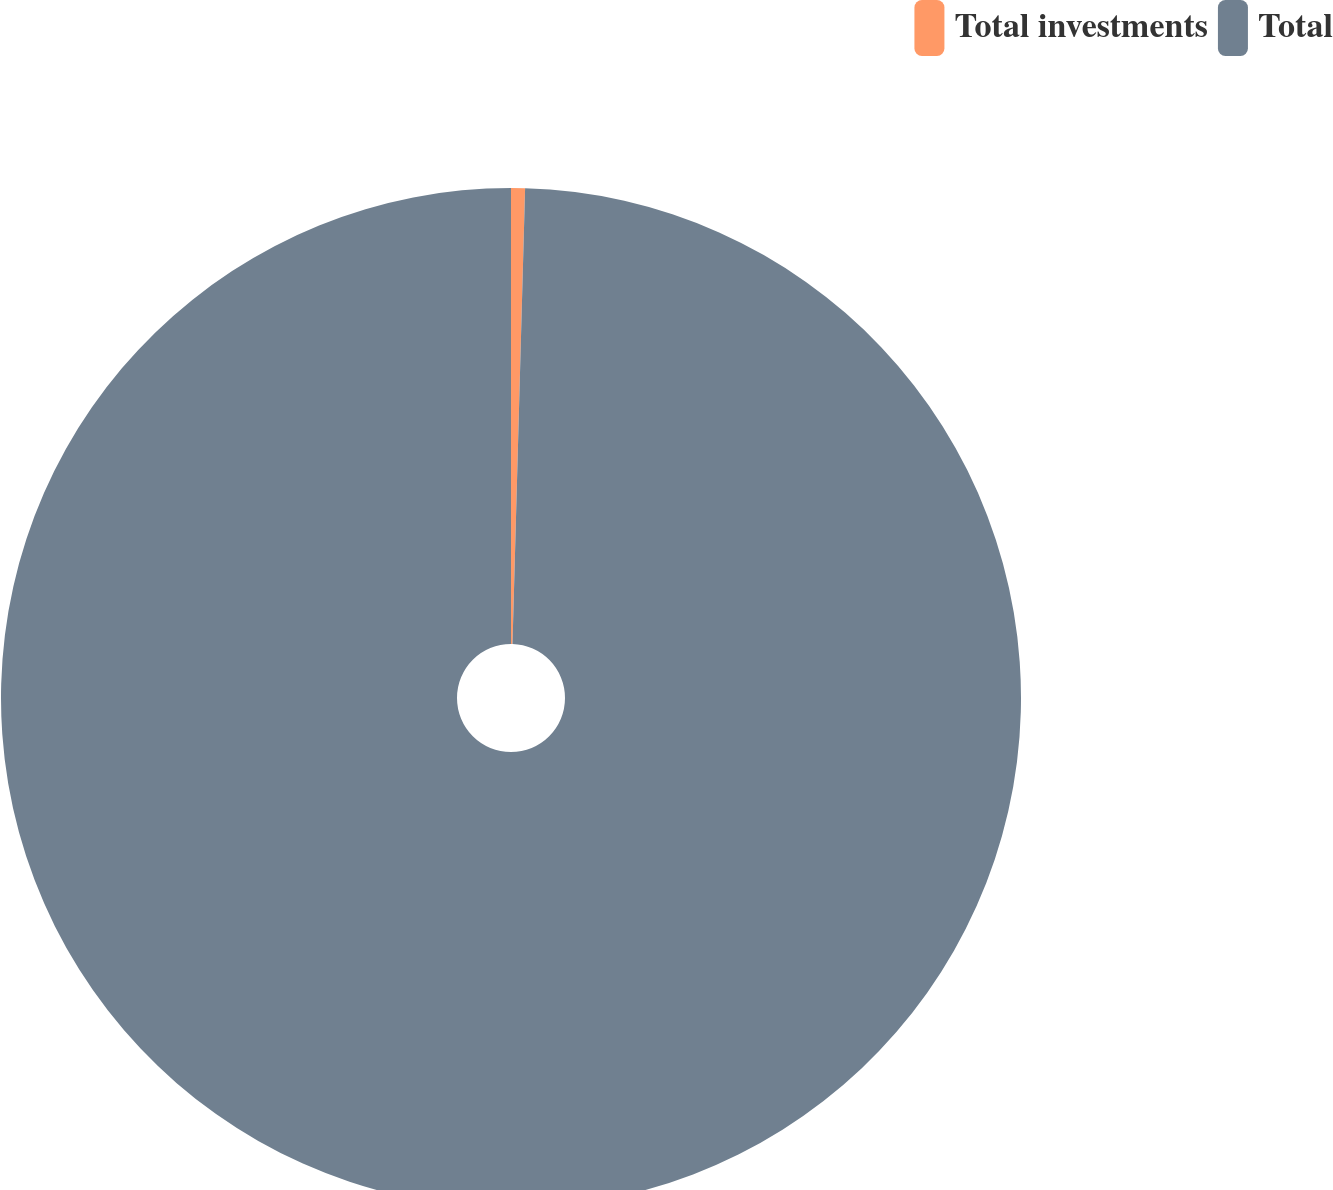<chart> <loc_0><loc_0><loc_500><loc_500><pie_chart><fcel>Total investments<fcel>Total<nl><fcel>0.44%<fcel>99.56%<nl></chart> 